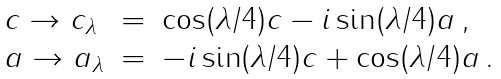<formula> <loc_0><loc_0><loc_500><loc_500>\begin{array} { l l l l } c \to c _ { \lambda } & = & \cos ( \lambda / 4 ) c - i \sin ( \lambda / 4 ) a \, , \\ a \to a _ { \lambda } & = & - i \sin ( \lambda / 4 ) c + \cos ( \lambda / 4 ) a \, . \end{array}</formula> 